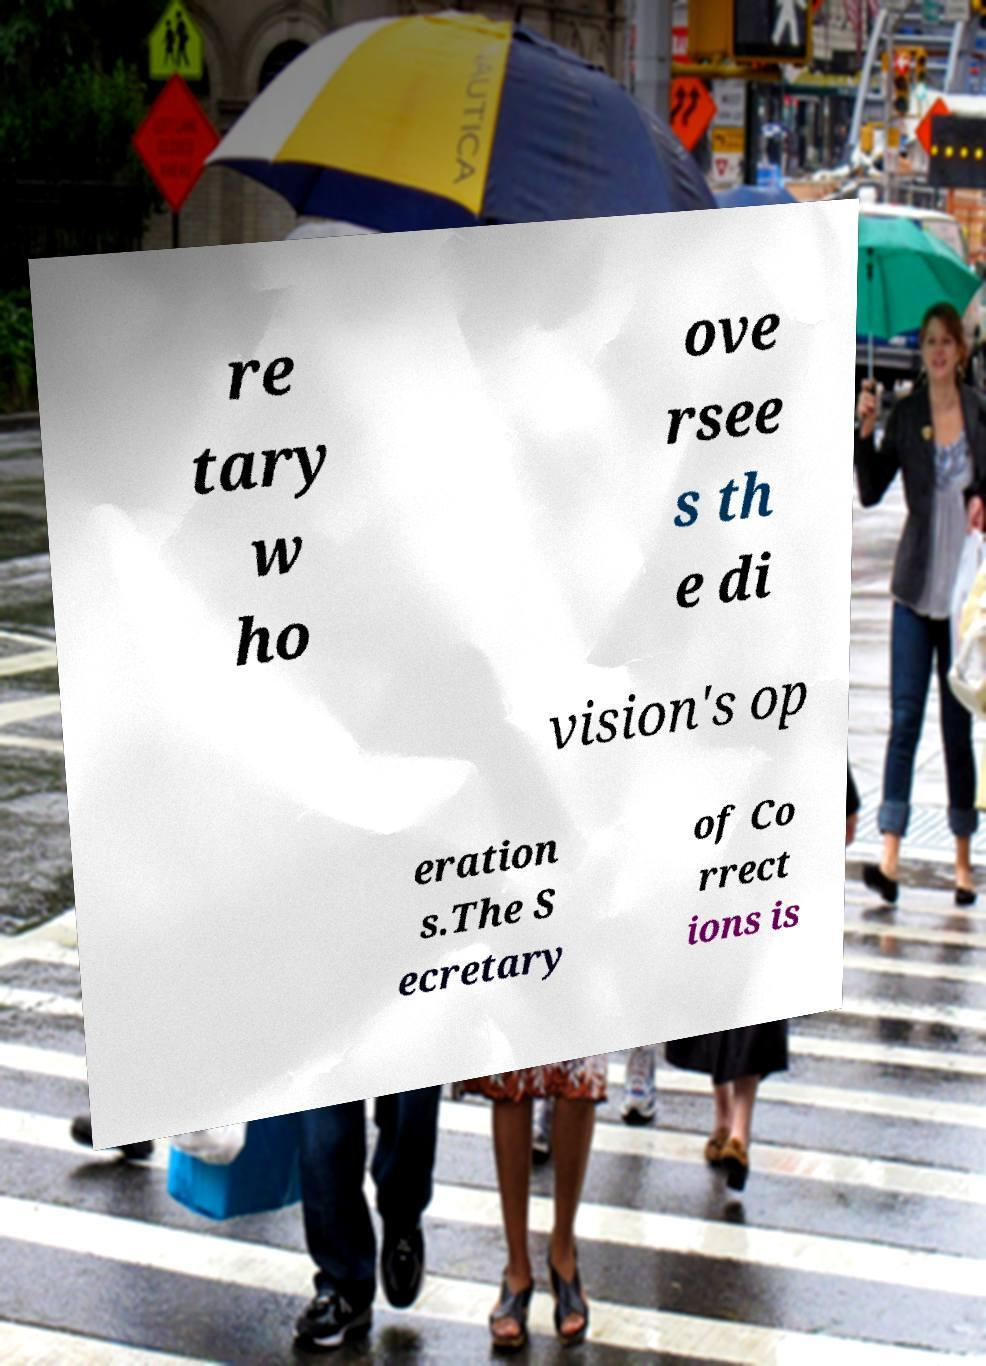There's text embedded in this image that I need extracted. Can you transcribe it verbatim? re tary w ho ove rsee s th e di vision's op eration s.The S ecretary of Co rrect ions is 